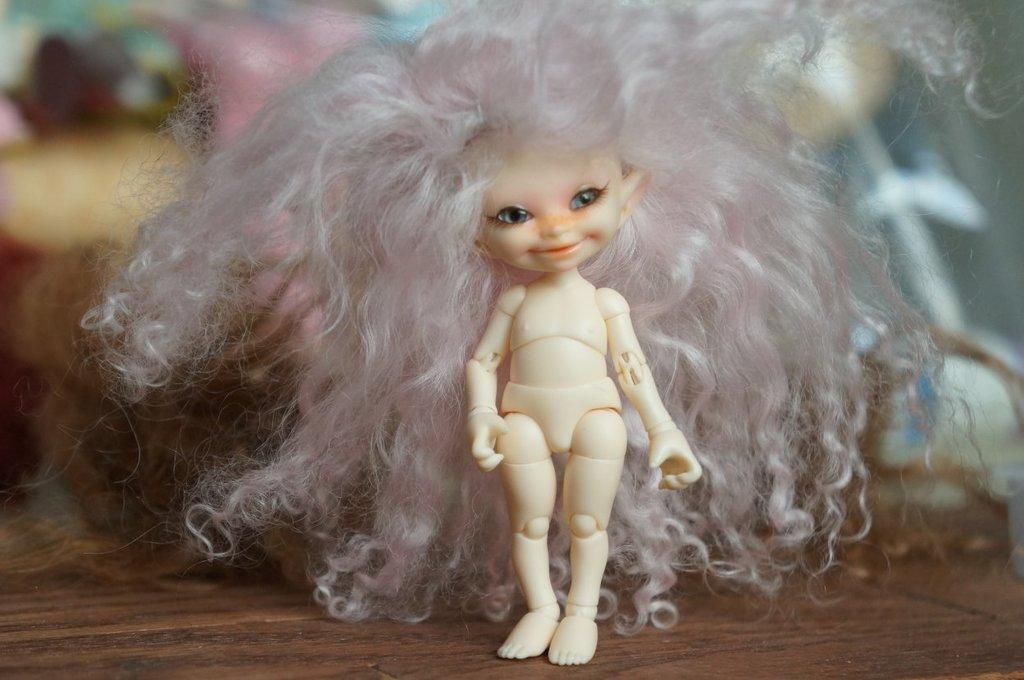What is the color of the doll in the image? The doll in the image is white. What colors are present in the doll's hair? The doll's hair has pink and white colors. On what surface is the doll placed in the image? The doll is on a brown color table. Can you describe the background of the image? The background of the image is blurred. What type of harmony or agreement is being discussed in the image? There is no discussion of harmony or agreement in the image; it features a white color doll with pink and white hair on a brown color table, and the background is blurred. 